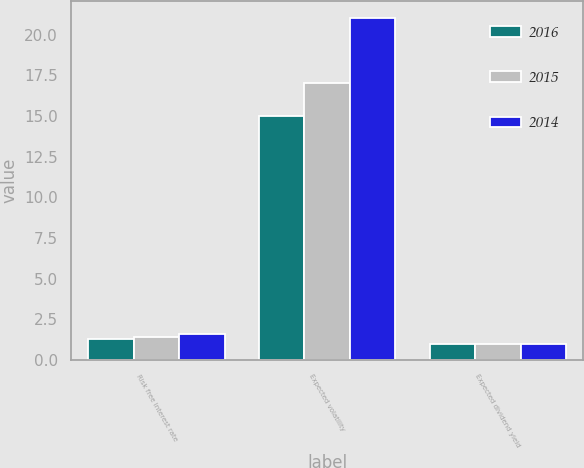<chart> <loc_0><loc_0><loc_500><loc_500><stacked_bar_chart><ecel><fcel>Risk free interest rate<fcel>Expected volatility<fcel>Expected dividend yield<nl><fcel>2016<fcel>1.3<fcel>15<fcel>1<nl><fcel>2015<fcel>1.4<fcel>17<fcel>1<nl><fcel>2014<fcel>1.6<fcel>21<fcel>1<nl></chart> 